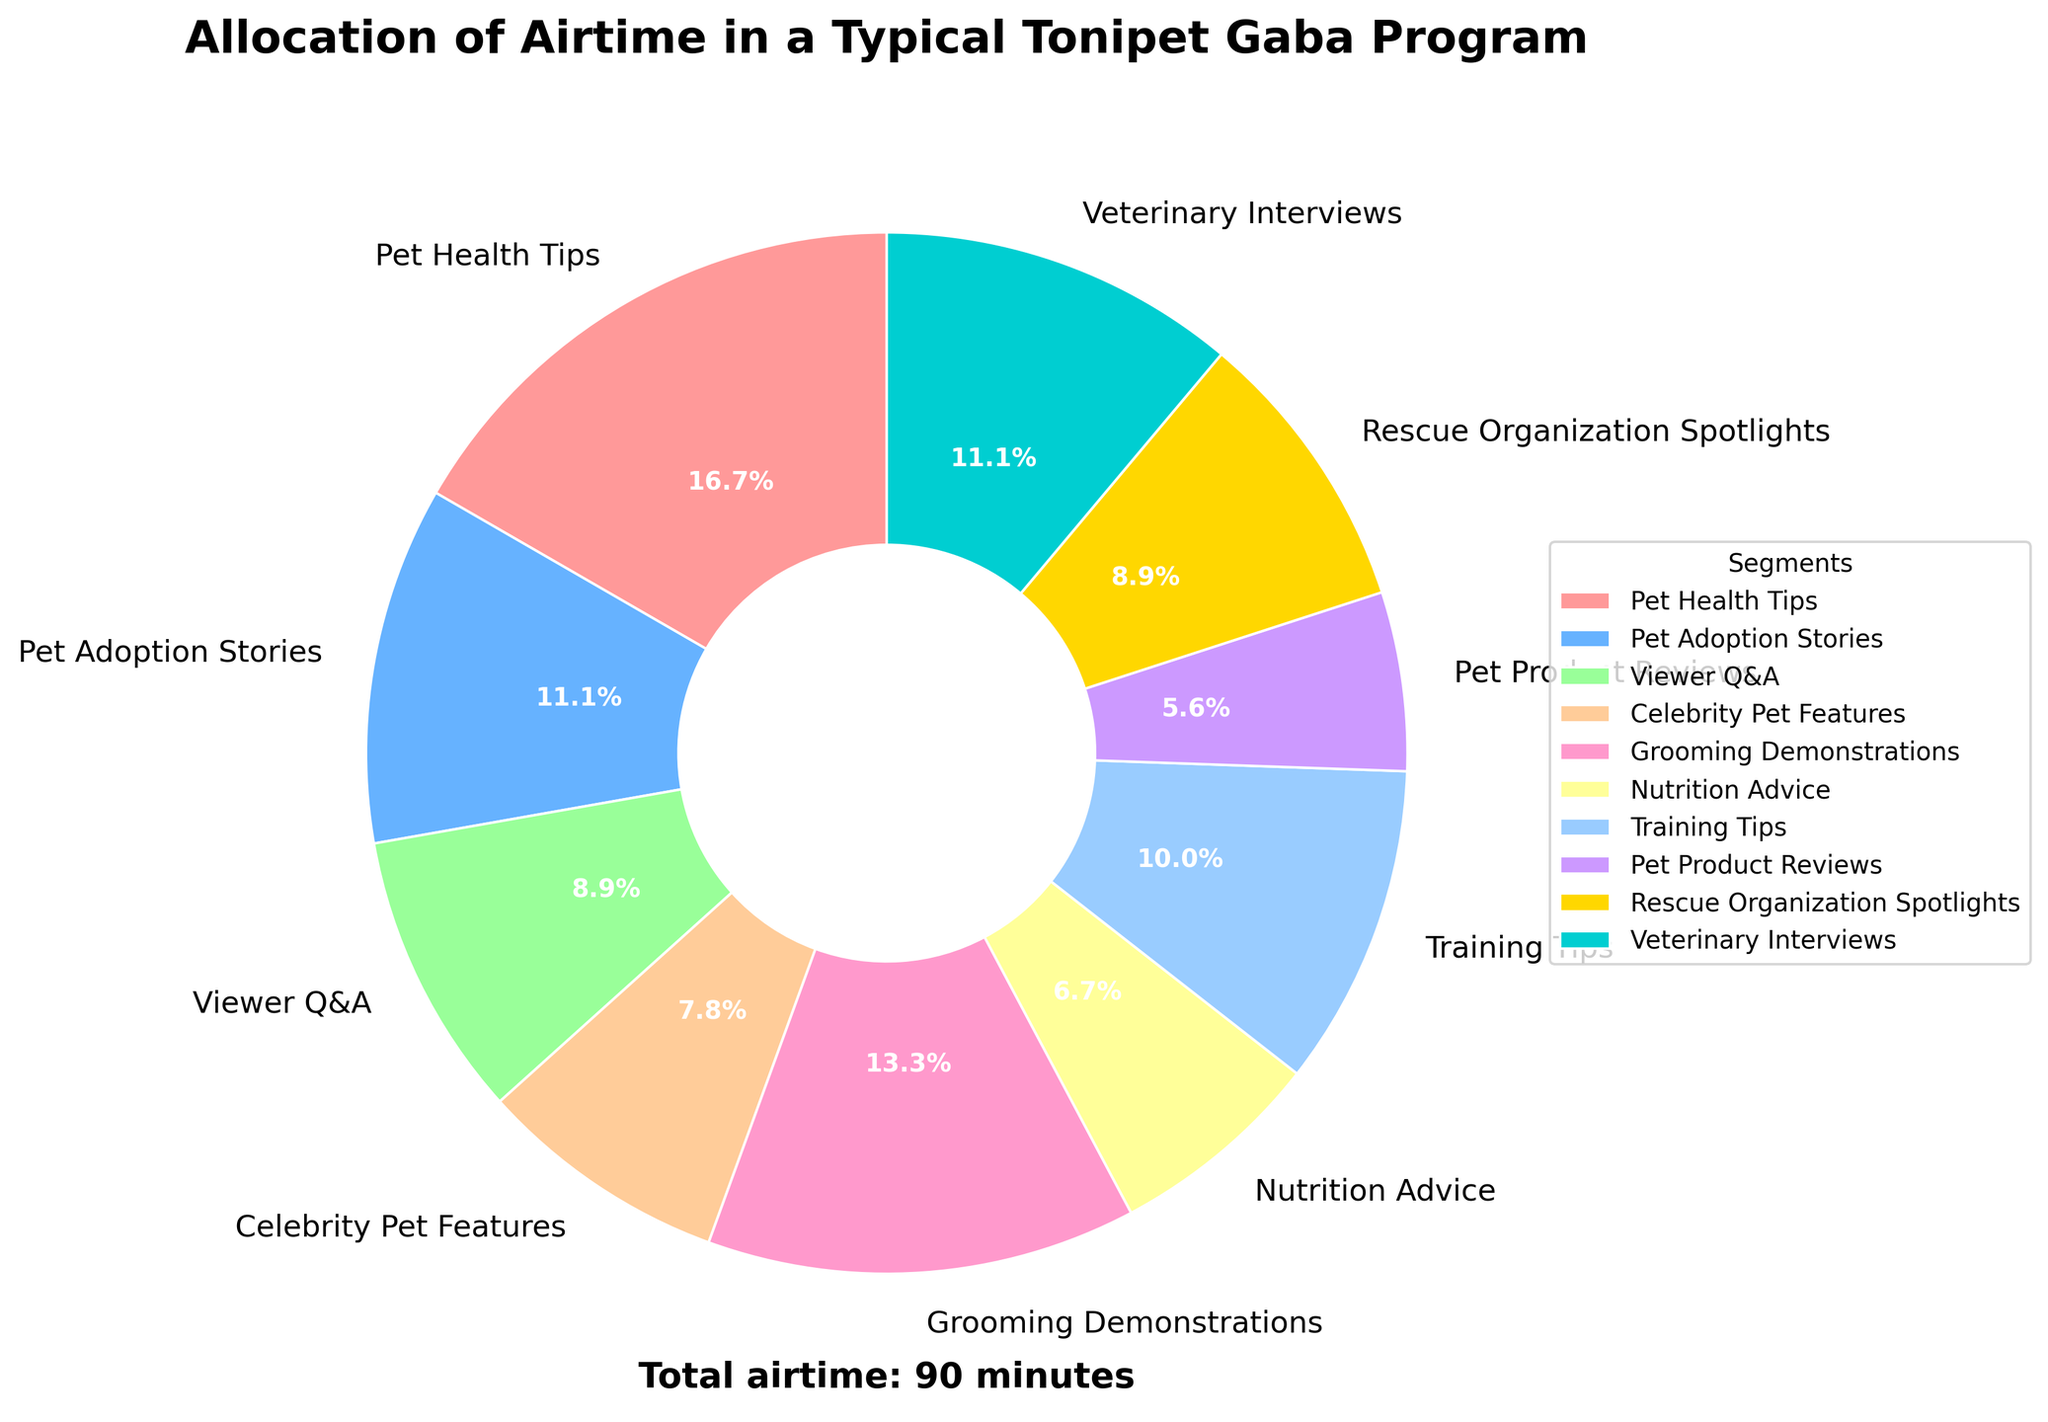Which segment gets the most airtime in a typical Tonipet Gaba program? The segment labeled "Pet Health Tips" occupies the largest wedge of the pie chart.
Answer: Pet Health Tips Which two segments have equal airtime? Both "Viewer Q&A" and "Rescue Organization Spotlights" have an equal size wedge, each representing 8 minutes.
Answer: Viewer Q&A, Rescue Organization Spotlights How much more airtime does "Pet Health Tips" get compared to "Pet Product Reviews"? "Pet Health Tips" has 15 minutes and "Pet Product Reviews" has 5 minutes, so the difference is 15 - 5 = 10 minutes.
Answer: 10 minutes What is the total airtime allocated for "Pet Adoption Stories" and "Celebrity Pet Features"? "Pet Adoption Stories" has 10 minutes and "Celebrity Pet Features" has 7 minutes, so the total is 10 + 7 = 17 minutes.
Answer: 17 minutes Which segment is represented by a wedge that is visually green? From the description of colors, the segment represented by the green color is "Viewer Q&A".
Answer: Viewer Q&A What is the combined airtime of "Grooming Demonstrations" and "Training Tips"? "Grooming Demonstrations" has 12 minutes and "Training Tips" has 9 minutes, so combined they have 12 + 9 = 21 minutes.
Answer: 21 minutes Which segment has the second-largest wedge in the pie chart? The second-largest wedge after "Pet Health Tips" belongs to "Grooming Demonstrations".
Answer: Grooming Demonstrations What’s the total airtime for all segments related to pet health (including "Pet Health Tips", "Nutrition Advice", and "Veterinary Interviews")? "Pet Health Tips" has 15 minutes, "Nutrition Advice" has 6 minutes, and "Veterinary Interviews" has 10 minutes, so the total is 15 + 6 + 10 = 31 minutes.
Answer: 31 minutes How many more minutes are allocated to "Veterinary Interviews" than to "Celebrity Pet Features"? "Veterinary Interviews" has 10 minutes while "Celebrity Pet Features" has 7 minutes, so there are 10 - 7 = 3 more minutes.
Answer: 3 minutes Which segment is visually represented by a gold color in the pie chart? The segment represented by the gold color is "Rescue Organization Spotlights".
Answer: Rescue Organization Spotlights 